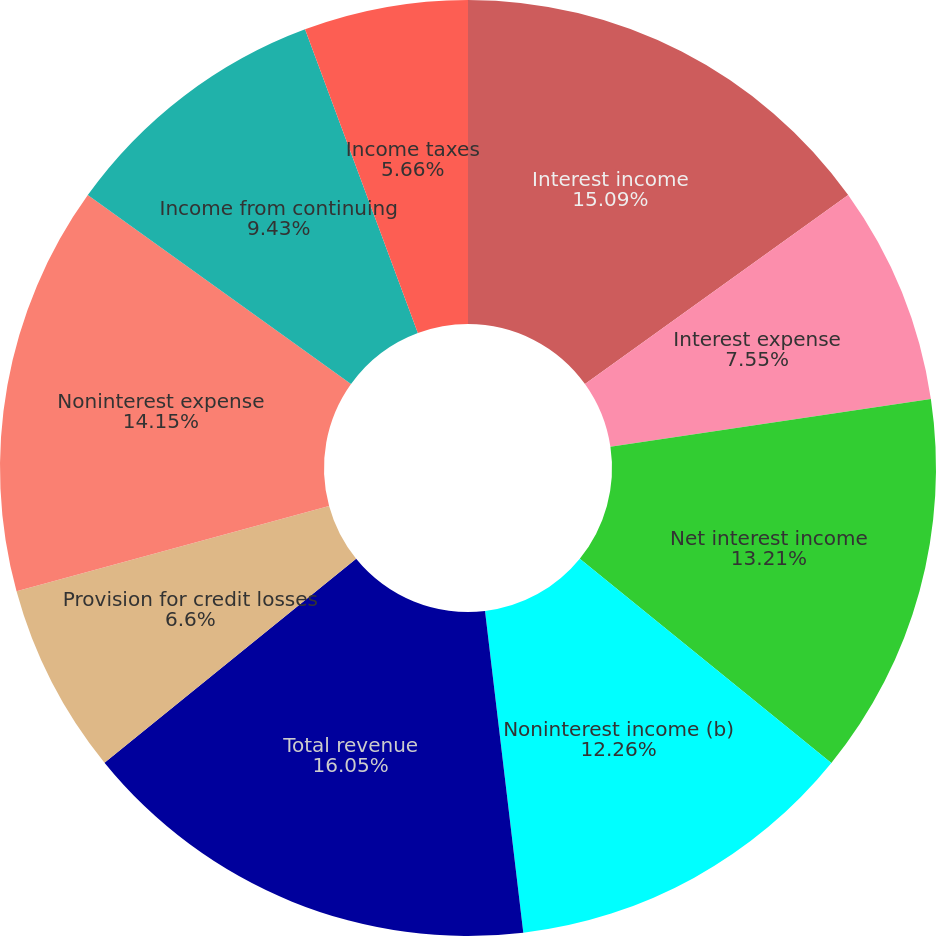<chart> <loc_0><loc_0><loc_500><loc_500><pie_chart><fcel>Interest income<fcel>Interest expense<fcel>Net interest income<fcel>Noninterest income (b)<fcel>Total revenue<fcel>Provision for credit losses<fcel>Noninterest expense<fcel>Income from continuing<fcel>Income taxes<nl><fcel>15.09%<fcel>7.55%<fcel>13.21%<fcel>12.26%<fcel>16.04%<fcel>6.6%<fcel>14.15%<fcel>9.43%<fcel>5.66%<nl></chart> 